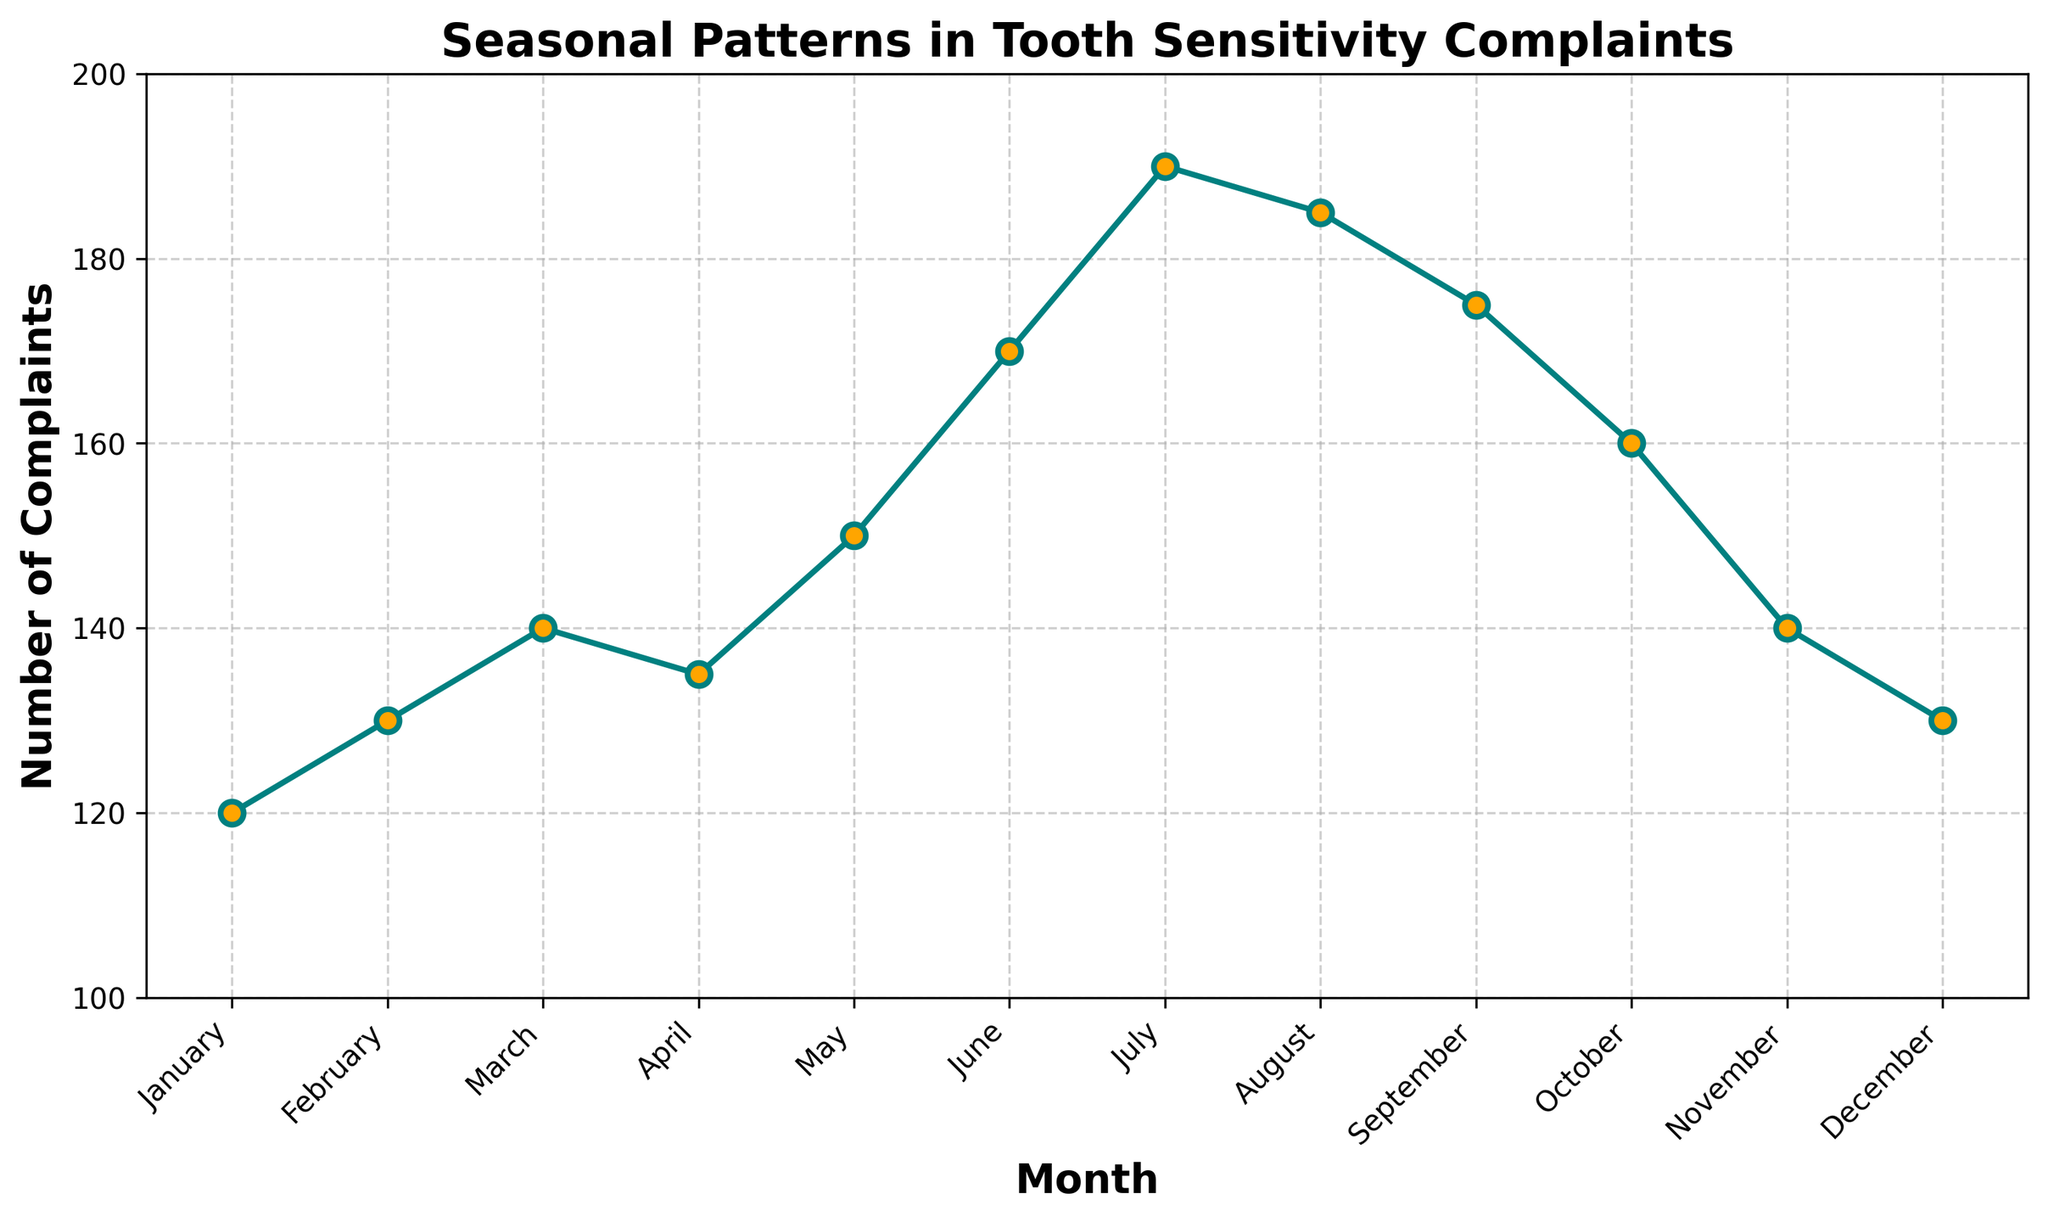Which month has the highest number of complaints? By looking at the plot, the month with the highest peak represents the highest number of complaints. July has the highest peak.
Answer: July Which month has the lowest number of complaints? The month with the smallest value on the y-axis, indicating the lowest number of complaints, is January.
Answer: January How many more complaints were there in July compared to January? The number of complaints in July is 190, and in January, it is 120. The difference is 190 - 120.
Answer: 70 What is the average number of complaints per month? Sum all the complaints for each month (120 + 130 + 140 + 135 + 150 + 170 + 190 + 185 + 175 + 160 + 140 + 130) and divide by the number of months (12). The sum is 1825, so 1825 / 12 = 152.08.
Answer: 152.08 In which months do complaints exceed 160? Identifying months with values greater than 160 on the y-axis, the months include June, July, August, and September.
Answer: June, July, August, September Which month shows a decrease in complaints compared to the previous month? Compare sequential months; April has fewer complaints (135) than March (140) and August has fewer complaints (185) than July (190).
Answer: April, August How many months have a complaints number between 130 and 170 inclusive? Count the months with a y-axis value between 130 and 170 (January, February, March, April, May, October, November, December). There are 8 months in total.
Answer: 8 What is the trend in complaints from January to June? Observing the trend line from January (120) to June (170), complaints increase gradually.
Answer: Increasing What is the median number of complaints across the year? Order the months by number of complaints: 120, 130, 130, 135, 140, 140, 150, 160, 170, 175, 185, 190. The middle values (6th and 7th) are 140 and 150. The median is (140 + 150) / 2 = 145.
Answer: 145 Which quarter has the highest total number of complaints? Calculate the sum for each quarter: Q1 (Jan-Mar): 120 + 130 + 140 = 390; Q2 (Apr-Jun): 135 + 150 + 170 = 455; Q3 (Jul-Sep): 190 + 185 + 175 = 550; Q4 (Oct-Dec): 160 + 140 + 130 = 430. Q3 has the highest total of 550.
Answer: Q3 